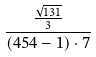<formula> <loc_0><loc_0><loc_500><loc_500>\frac { \frac { \sqrt { 1 3 1 } } { 3 } } { ( 4 5 4 - 1 ) \cdot 7 }</formula> 